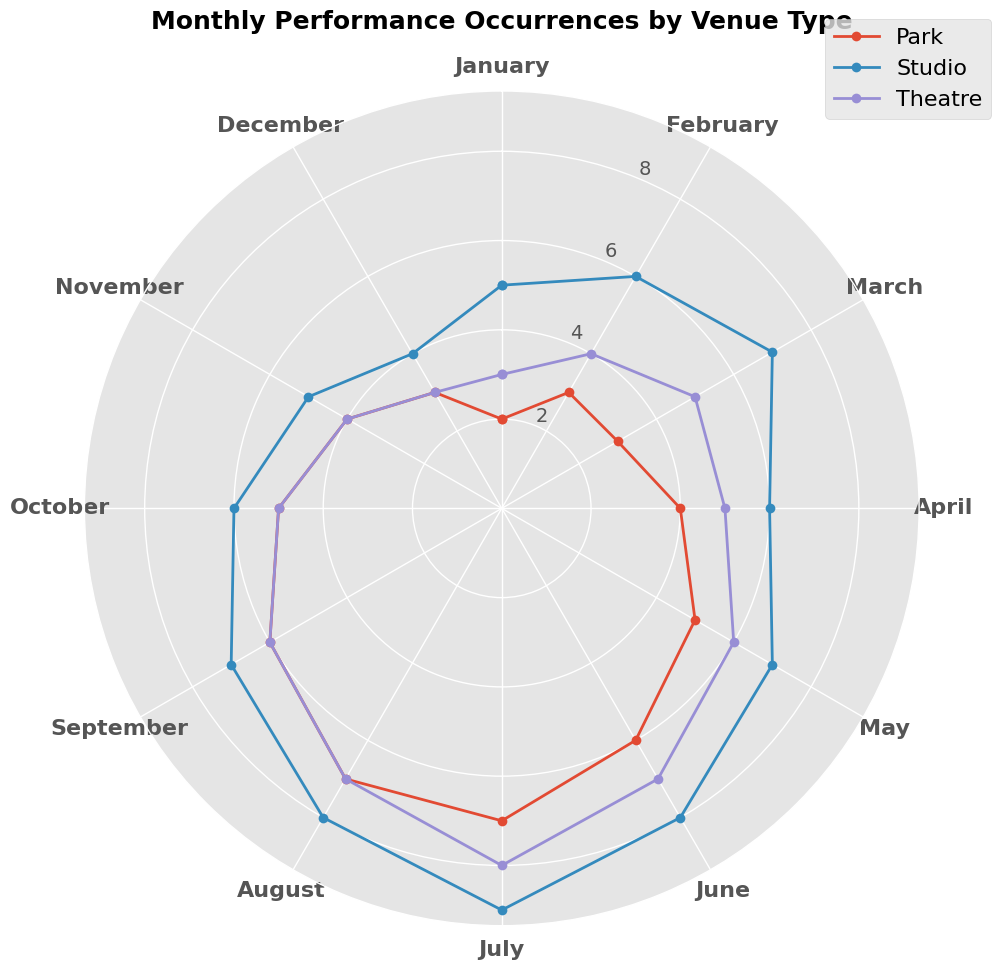Which venue type has the highest number of occurrences in July? To find this, check the angles corresponding to July for each venue type and compare the heights of the points. The points are represented by markers, and the highest marker indicates the venue type with the most occurrences. Studio has the highest marker in July.
Answer: Studio How does the number of park occurrences in December compare with those in November? Look at the data points for park occurrences in November and December. In November, the park has 4 occurrences, and in December, it has 3. So, November has one more occurrence than December.
Answer: November has 1 more What's the total number of occurrences across all venues in May? Sum the occurrences for parks, studios, and theatres in May. The occurrences are 5 (Park), 7 (Studio), and 6 (Theatre). So, the total is 5 + 7 + 6.
Answer: 18 Compare the trends in venue occurrences for August and September. What do you observe? Look at the angles for August and September and compare the heights of the markers for each venue. In both months, park, studio, and theatre occurrences show a slight decrease from August to September. Studios have 8 in August and 7 in September, Parks have 7 in August and 6 in September, and Theatres have 7 in August and 6 in September.
Answer: Slight decrease for all What is the average monthly occurrence for theatres from January to June? Find the sum of occurrences for theatres from January to June and then divide by the number of months. The occurrences are 3 (Jan), 4 (Feb), 5 (Mar), 5 (Apr), 6 (May), and 7 (Jun). The sum is 3 + 4 + 5 + 5 + 6 + 7 = 30. Divide by 6.
Answer: 5 In which month do parks see the most occurrences, and what is the total number for that month? Identify the month with the highest marker for parks, which is July. The number of occurrences for July is 7.
Answer: July, 7 Does the trend of studio occurrences show any significant peaks or dips throughout the year? Observe the plot for the studio occurrences across all months. From January to July, there is a gradual increase peaking in July (9). Then, a slight decrease follows till December with no dramatic peaks or dips.
Answer: Peak in July Which two consecutive months show the steepest increase in theatre occurrences? Look at the theatre occurrences trend and identify the two months with the most significant rise in marker height. The largest increase is from January (3) to February (4) and February (4) to March (5), with specific attention. The steepest is clearly from January to March.
Answer: January to February In December, which venue type has the lowest number of occurrences, and what is that number? Look at the markers for December for each venue. The lowest point corresponds to Studios with 4 occurrences.
Answer: Studio, 4 